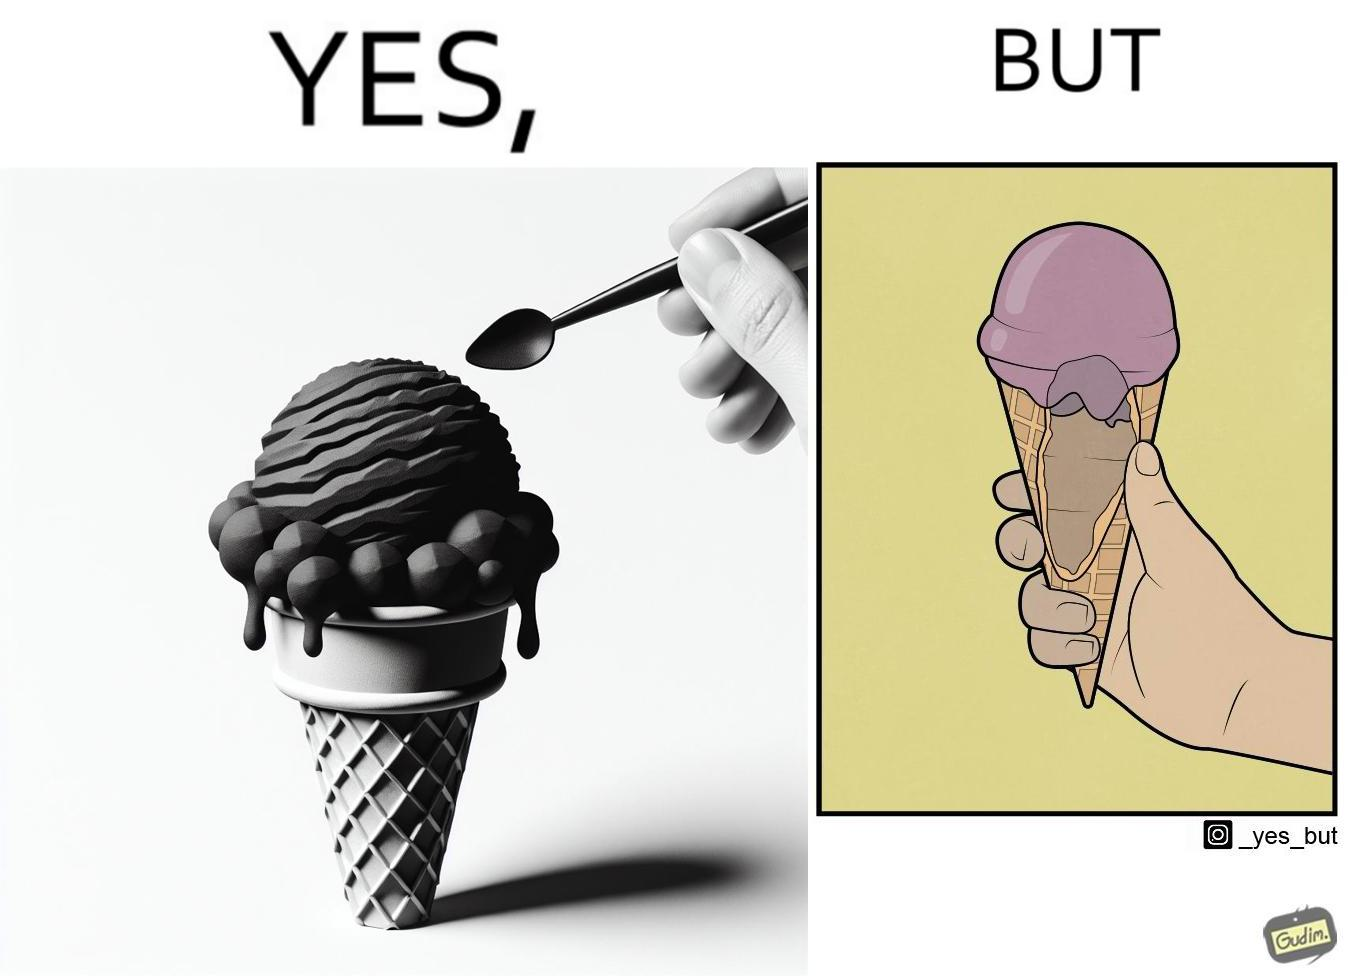What does this image depict? The image is ironic, because in one image the softy cone is shown filled with softy but in second image it is visible that only the top of the cone is filled and at the inside the cone is vacant 